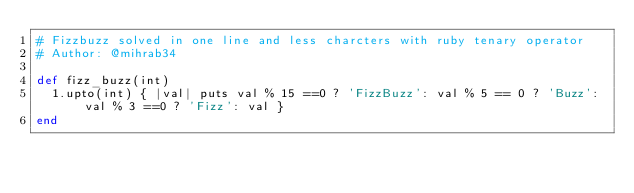Convert code to text. <code><loc_0><loc_0><loc_500><loc_500><_Ruby_># Fizzbuzz solved in one line and less charcters with ruby tenary operator
# Author: @mihrab34

def fizz_buzz(int)
  1.upto(int) { |val| puts val % 15 ==0 ? 'FizzBuzz': val % 5 == 0 ? 'Buzz': val % 3 ==0 ? 'Fizz': val }
end</code> 